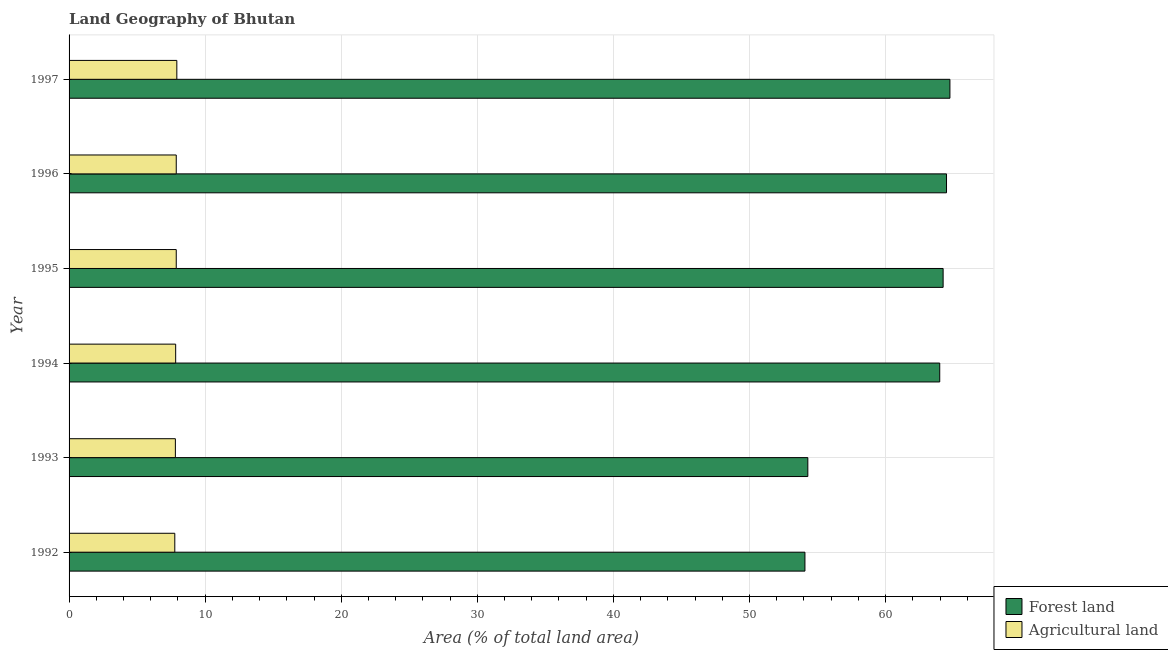How many different coloured bars are there?
Provide a short and direct response. 2. Are the number of bars on each tick of the Y-axis equal?
Your answer should be very brief. Yes. How many bars are there on the 5th tick from the bottom?
Give a very brief answer. 2. What is the label of the 5th group of bars from the top?
Your answer should be compact. 1993. In how many cases, is the number of bars for a given year not equal to the number of legend labels?
Provide a short and direct response. 0. What is the percentage of land area under forests in 1993?
Your response must be concise. 54.29. Across all years, what is the maximum percentage of land area under agriculture?
Offer a terse response. 7.92. Across all years, what is the minimum percentage of land area under forests?
Your response must be concise. 54.08. What is the total percentage of land area under forests in the graph?
Make the answer very short. 365.78. What is the difference between the percentage of land area under forests in 1993 and that in 1994?
Give a very brief answer. -9.69. What is the difference between the percentage of land area under agriculture in 1996 and the percentage of land area under forests in 1993?
Your answer should be compact. -46.41. What is the average percentage of land area under agriculture per year?
Your response must be concise. 7.85. In the year 1996, what is the difference between the percentage of land area under agriculture and percentage of land area under forests?
Your response must be concise. -56.6. In how many years, is the percentage of land area under agriculture greater than 24 %?
Make the answer very short. 0. What is the ratio of the percentage of land area under forests in 1992 to that in 1995?
Your answer should be compact. 0.84. Is the difference between the percentage of land area under forests in 1994 and 1996 greater than the difference between the percentage of land area under agriculture in 1994 and 1996?
Your answer should be very brief. No. What is the difference between the highest and the second highest percentage of land area under forests?
Provide a succinct answer. 0.25. What is the difference between the highest and the lowest percentage of land area under forests?
Give a very brief answer. 10.65. In how many years, is the percentage of land area under agriculture greater than the average percentage of land area under agriculture taken over all years?
Provide a succinct answer. 3. Is the sum of the percentage of land area under agriculture in 1993 and 1997 greater than the maximum percentage of land area under forests across all years?
Your answer should be very brief. No. What does the 1st bar from the top in 1995 represents?
Your response must be concise. Agricultural land. What does the 1st bar from the bottom in 1992 represents?
Your response must be concise. Forest land. How many bars are there?
Offer a terse response. 12. How many years are there in the graph?
Provide a succinct answer. 6. What is the difference between two consecutive major ticks on the X-axis?
Offer a very short reply. 10. Does the graph contain any zero values?
Ensure brevity in your answer.  No. Does the graph contain grids?
Your answer should be compact. Yes. How many legend labels are there?
Provide a succinct answer. 2. What is the title of the graph?
Keep it short and to the point. Land Geography of Bhutan. Does "Working only" appear as one of the legend labels in the graph?
Provide a short and direct response. No. What is the label or title of the X-axis?
Provide a succinct answer. Area (% of total land area). What is the Area (% of total land area) in Forest land in 1992?
Provide a short and direct response. 54.08. What is the Area (% of total land area) of Agricultural land in 1992?
Provide a succinct answer. 7.77. What is the Area (% of total land area) of Forest land in 1993?
Ensure brevity in your answer.  54.29. What is the Area (% of total land area) in Agricultural land in 1993?
Offer a terse response. 7.81. What is the Area (% of total land area) in Forest land in 1994?
Keep it short and to the point. 63.98. What is the Area (% of total land area) of Agricultural land in 1994?
Your response must be concise. 7.83. What is the Area (% of total land area) of Forest land in 1995?
Offer a very short reply. 64.23. What is the Area (% of total land area) of Agricultural land in 1995?
Ensure brevity in your answer.  7.88. What is the Area (% of total land area) of Forest land in 1996?
Provide a succinct answer. 64.48. What is the Area (% of total land area) of Agricultural land in 1996?
Your answer should be very brief. 7.88. What is the Area (% of total land area) in Forest land in 1997?
Offer a very short reply. 64.73. What is the Area (% of total land area) of Agricultural land in 1997?
Provide a short and direct response. 7.92. Across all years, what is the maximum Area (% of total land area) of Forest land?
Keep it short and to the point. 64.73. Across all years, what is the maximum Area (% of total land area) in Agricultural land?
Offer a very short reply. 7.92. Across all years, what is the minimum Area (% of total land area) in Forest land?
Keep it short and to the point. 54.08. Across all years, what is the minimum Area (% of total land area) of Agricultural land?
Your answer should be very brief. 7.77. What is the total Area (% of total land area) of Forest land in the graph?
Keep it short and to the point. 365.78. What is the total Area (% of total land area) in Agricultural land in the graph?
Your response must be concise. 47.09. What is the difference between the Area (% of total land area) in Forest land in 1992 and that in 1993?
Provide a succinct answer. -0.21. What is the difference between the Area (% of total land area) in Agricultural land in 1992 and that in 1993?
Make the answer very short. -0.04. What is the difference between the Area (% of total land area) of Forest land in 1992 and that in 1994?
Keep it short and to the point. -9.91. What is the difference between the Area (% of total land area) of Agricultural land in 1992 and that in 1994?
Your answer should be very brief. -0.06. What is the difference between the Area (% of total land area) of Forest land in 1992 and that in 1995?
Your answer should be very brief. -10.15. What is the difference between the Area (% of total land area) of Agricultural land in 1992 and that in 1995?
Your answer should be compact. -0.11. What is the difference between the Area (% of total land area) of Forest land in 1992 and that in 1996?
Your answer should be compact. -10.4. What is the difference between the Area (% of total land area) of Agricultural land in 1992 and that in 1996?
Give a very brief answer. -0.11. What is the difference between the Area (% of total land area) in Forest land in 1992 and that in 1997?
Make the answer very short. -10.65. What is the difference between the Area (% of total land area) of Agricultural land in 1992 and that in 1997?
Provide a succinct answer. -0.15. What is the difference between the Area (% of total land area) in Forest land in 1993 and that in 1994?
Your answer should be compact. -9.69. What is the difference between the Area (% of total land area) in Agricultural land in 1993 and that in 1994?
Ensure brevity in your answer.  -0.02. What is the difference between the Area (% of total land area) of Forest land in 1993 and that in 1995?
Provide a succinct answer. -9.94. What is the difference between the Area (% of total land area) of Agricultural land in 1993 and that in 1995?
Your answer should be compact. -0.06. What is the difference between the Area (% of total land area) in Forest land in 1993 and that in 1996?
Your answer should be very brief. -10.19. What is the difference between the Area (% of total land area) of Agricultural land in 1993 and that in 1996?
Your response must be concise. -0.06. What is the difference between the Area (% of total land area) of Forest land in 1993 and that in 1997?
Keep it short and to the point. -10.44. What is the difference between the Area (% of total land area) in Agricultural land in 1993 and that in 1997?
Your response must be concise. -0.11. What is the difference between the Area (% of total land area) of Forest land in 1994 and that in 1995?
Make the answer very short. -0.25. What is the difference between the Area (% of total land area) of Agricultural land in 1994 and that in 1995?
Your response must be concise. -0.04. What is the difference between the Area (% of total land area) in Forest land in 1994 and that in 1996?
Your answer should be very brief. -0.5. What is the difference between the Area (% of total land area) of Agricultural land in 1994 and that in 1996?
Ensure brevity in your answer.  -0.04. What is the difference between the Area (% of total land area) of Forest land in 1994 and that in 1997?
Your response must be concise. -0.75. What is the difference between the Area (% of total land area) in Agricultural land in 1994 and that in 1997?
Provide a short and direct response. -0.09. What is the difference between the Area (% of total land area) in Forest land in 1995 and that in 1996?
Your answer should be very brief. -0.25. What is the difference between the Area (% of total land area) of Forest land in 1995 and that in 1997?
Your answer should be compact. -0.5. What is the difference between the Area (% of total land area) of Agricultural land in 1995 and that in 1997?
Your response must be concise. -0.04. What is the difference between the Area (% of total land area) in Forest land in 1996 and that in 1997?
Give a very brief answer. -0.25. What is the difference between the Area (% of total land area) of Agricultural land in 1996 and that in 1997?
Provide a succinct answer. -0.04. What is the difference between the Area (% of total land area) in Forest land in 1992 and the Area (% of total land area) in Agricultural land in 1993?
Keep it short and to the point. 46.26. What is the difference between the Area (% of total land area) in Forest land in 1992 and the Area (% of total land area) in Agricultural land in 1994?
Your answer should be compact. 46.24. What is the difference between the Area (% of total land area) in Forest land in 1992 and the Area (% of total land area) in Agricultural land in 1995?
Your answer should be compact. 46.2. What is the difference between the Area (% of total land area) in Forest land in 1992 and the Area (% of total land area) in Agricultural land in 1996?
Your response must be concise. 46.2. What is the difference between the Area (% of total land area) of Forest land in 1992 and the Area (% of total land area) of Agricultural land in 1997?
Offer a terse response. 46.16. What is the difference between the Area (% of total land area) of Forest land in 1993 and the Area (% of total land area) of Agricultural land in 1994?
Provide a succinct answer. 46.45. What is the difference between the Area (% of total land area) of Forest land in 1993 and the Area (% of total land area) of Agricultural land in 1995?
Provide a short and direct response. 46.41. What is the difference between the Area (% of total land area) of Forest land in 1993 and the Area (% of total land area) of Agricultural land in 1996?
Provide a succinct answer. 46.41. What is the difference between the Area (% of total land area) in Forest land in 1993 and the Area (% of total land area) in Agricultural land in 1997?
Make the answer very short. 46.37. What is the difference between the Area (% of total land area) of Forest land in 1994 and the Area (% of total land area) of Agricultural land in 1995?
Provide a short and direct response. 56.1. What is the difference between the Area (% of total land area) in Forest land in 1994 and the Area (% of total land area) in Agricultural land in 1996?
Your answer should be very brief. 56.1. What is the difference between the Area (% of total land area) of Forest land in 1994 and the Area (% of total land area) of Agricultural land in 1997?
Provide a short and direct response. 56.06. What is the difference between the Area (% of total land area) of Forest land in 1995 and the Area (% of total land area) of Agricultural land in 1996?
Provide a succinct answer. 56.35. What is the difference between the Area (% of total land area) in Forest land in 1995 and the Area (% of total land area) in Agricultural land in 1997?
Your response must be concise. 56.31. What is the difference between the Area (% of total land area) of Forest land in 1996 and the Area (% of total land area) of Agricultural land in 1997?
Keep it short and to the point. 56.56. What is the average Area (% of total land area) of Forest land per year?
Ensure brevity in your answer.  60.96. What is the average Area (% of total land area) in Agricultural land per year?
Offer a terse response. 7.85. In the year 1992, what is the difference between the Area (% of total land area) in Forest land and Area (% of total land area) in Agricultural land?
Your answer should be compact. 46.31. In the year 1993, what is the difference between the Area (% of total land area) in Forest land and Area (% of total land area) in Agricultural land?
Offer a terse response. 46.48. In the year 1994, what is the difference between the Area (% of total land area) in Forest land and Area (% of total land area) in Agricultural land?
Offer a very short reply. 56.15. In the year 1995, what is the difference between the Area (% of total land area) of Forest land and Area (% of total land area) of Agricultural land?
Keep it short and to the point. 56.35. In the year 1996, what is the difference between the Area (% of total land area) in Forest land and Area (% of total land area) in Agricultural land?
Provide a short and direct response. 56.6. In the year 1997, what is the difference between the Area (% of total land area) in Forest land and Area (% of total land area) in Agricultural land?
Your answer should be very brief. 56.81. What is the ratio of the Area (% of total land area) of Forest land in 1992 to that in 1993?
Provide a succinct answer. 1. What is the ratio of the Area (% of total land area) of Forest land in 1992 to that in 1994?
Your answer should be very brief. 0.85. What is the ratio of the Area (% of total land area) of Forest land in 1992 to that in 1995?
Your response must be concise. 0.84. What is the ratio of the Area (% of total land area) in Agricultural land in 1992 to that in 1995?
Provide a short and direct response. 0.99. What is the ratio of the Area (% of total land area) in Forest land in 1992 to that in 1996?
Provide a succinct answer. 0.84. What is the ratio of the Area (% of total land area) of Agricultural land in 1992 to that in 1996?
Your answer should be compact. 0.99. What is the ratio of the Area (% of total land area) of Forest land in 1992 to that in 1997?
Offer a terse response. 0.84. What is the ratio of the Area (% of total land area) of Agricultural land in 1992 to that in 1997?
Offer a terse response. 0.98. What is the ratio of the Area (% of total land area) of Forest land in 1993 to that in 1994?
Ensure brevity in your answer.  0.85. What is the ratio of the Area (% of total land area) of Agricultural land in 1993 to that in 1994?
Your answer should be very brief. 1. What is the ratio of the Area (% of total land area) in Forest land in 1993 to that in 1995?
Give a very brief answer. 0.85. What is the ratio of the Area (% of total land area) in Forest land in 1993 to that in 1996?
Provide a succinct answer. 0.84. What is the ratio of the Area (% of total land area) of Forest land in 1993 to that in 1997?
Provide a short and direct response. 0.84. What is the ratio of the Area (% of total land area) of Agricultural land in 1993 to that in 1997?
Offer a very short reply. 0.99. What is the ratio of the Area (% of total land area) in Forest land in 1994 to that in 1996?
Make the answer very short. 0.99. What is the ratio of the Area (% of total land area) in Forest land in 1994 to that in 1997?
Your answer should be very brief. 0.99. What is the ratio of the Area (% of total land area) of Agricultural land in 1994 to that in 1997?
Your answer should be compact. 0.99. What is the ratio of the Area (% of total land area) in Agricultural land in 1995 to that in 1996?
Provide a succinct answer. 1. What is the ratio of the Area (% of total land area) in Forest land in 1995 to that in 1997?
Provide a succinct answer. 0.99. What is the ratio of the Area (% of total land area) in Forest land in 1996 to that in 1997?
Offer a terse response. 1. What is the ratio of the Area (% of total land area) of Agricultural land in 1996 to that in 1997?
Make the answer very short. 0.99. What is the difference between the highest and the second highest Area (% of total land area) of Forest land?
Your answer should be very brief. 0.25. What is the difference between the highest and the second highest Area (% of total land area) of Agricultural land?
Your answer should be compact. 0.04. What is the difference between the highest and the lowest Area (% of total land area) in Forest land?
Offer a terse response. 10.65. What is the difference between the highest and the lowest Area (% of total land area) of Agricultural land?
Offer a terse response. 0.15. 